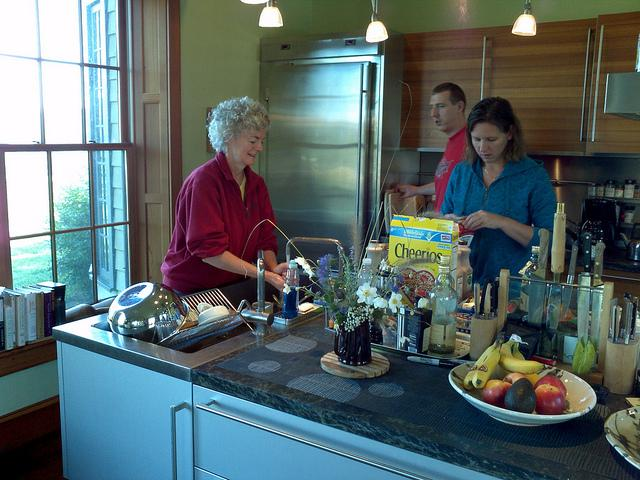What time of day is it? morning 